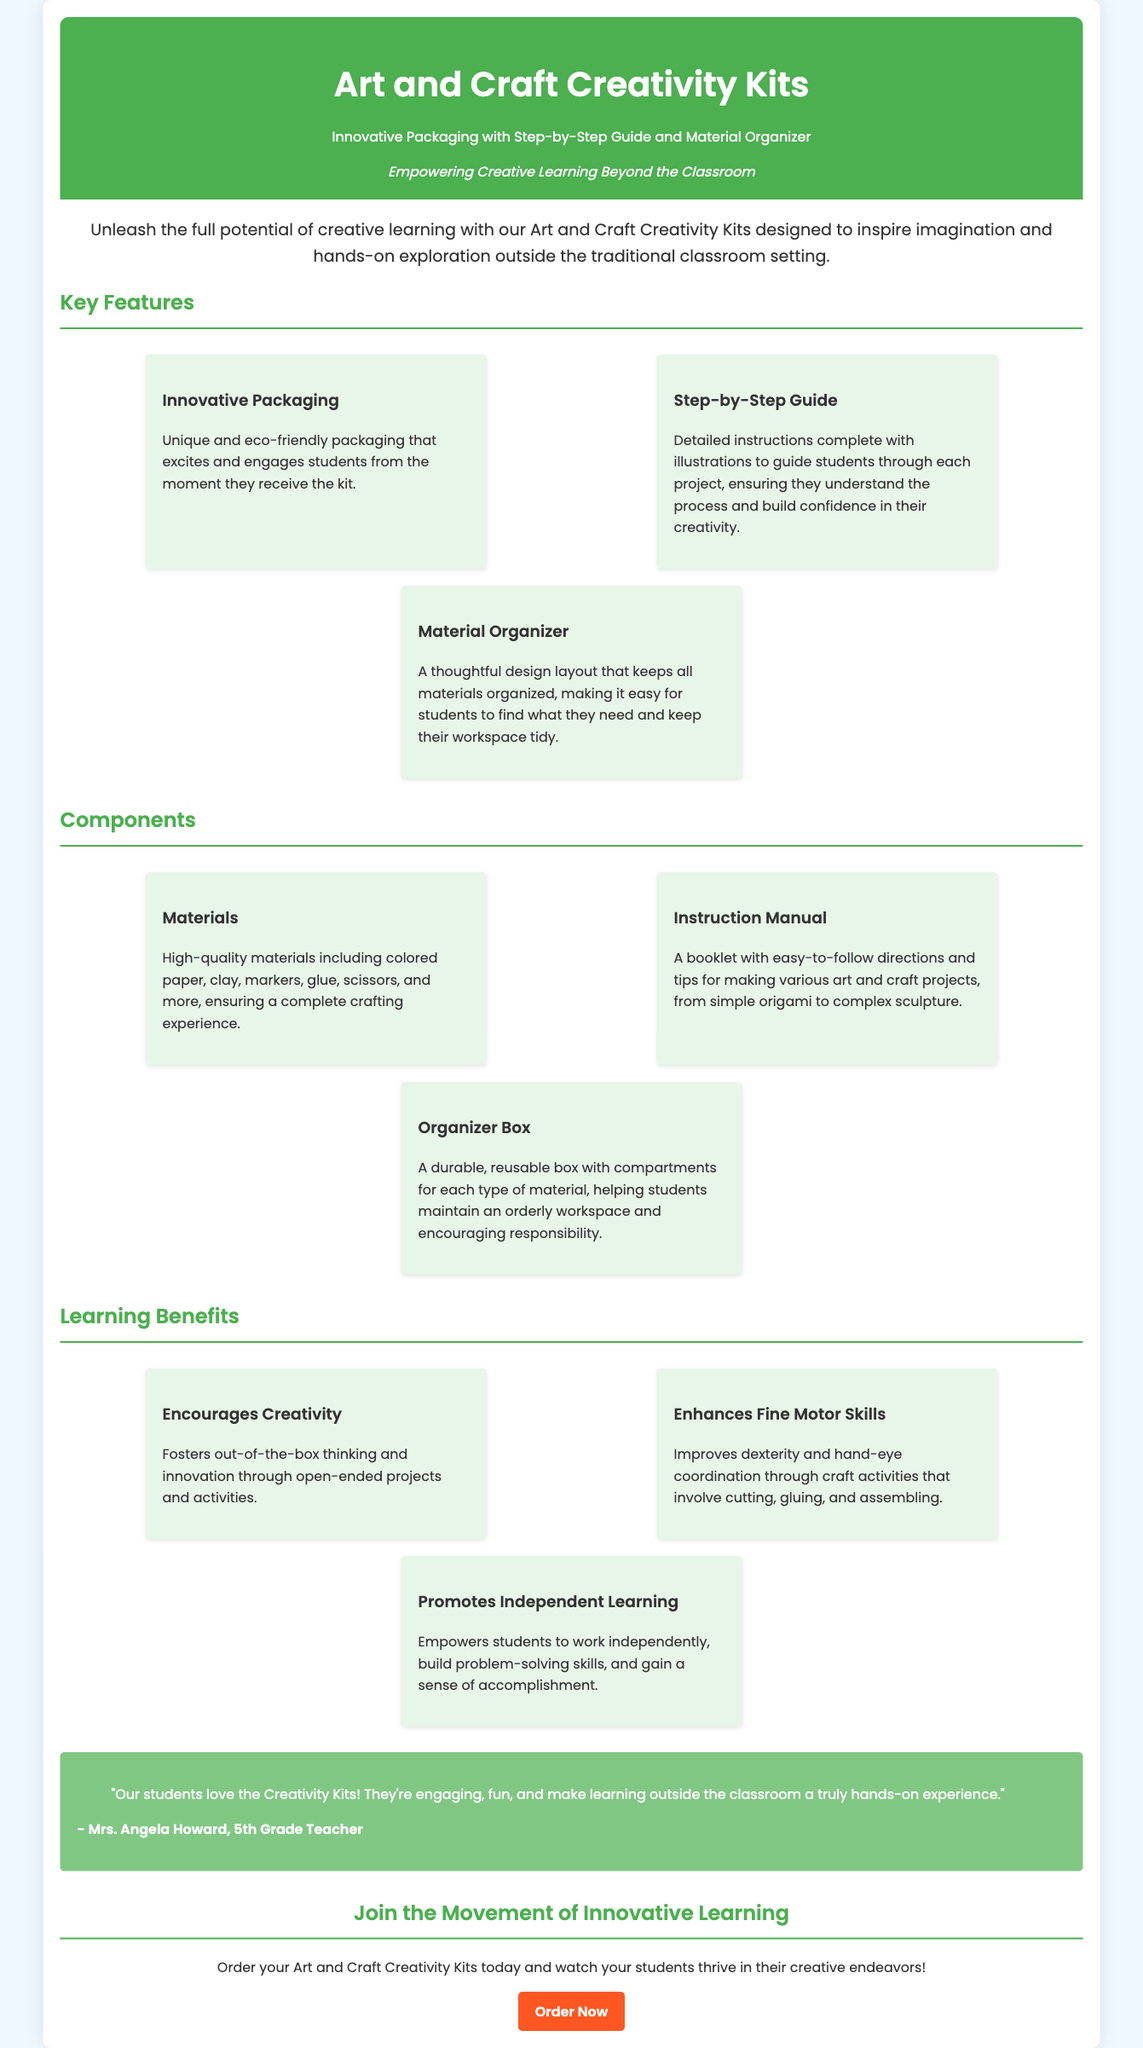What is the title of the product? The title of the product is prominently displayed in the header section of the document.
Answer: Art and Craft Creativity Kits What does the packaging feature? The document specifies key features of the product, one of which is innovative packaging.
Answer: Innovative Packaging How many components are listed in the document? The document provides a section for components and lists three individual items.
Answer: Three Who is quoted in the testimonial? The testimonial section includes a quote attributed to a specific person, identified in the document.
Answer: Mrs. Angela Howard What is one benefit of the creativity kits mentioned in the document? The document highlights several benefits, one of which encourages creativity.
Answer: Encourages Creativity What type of materials are included in the kits? The document provides details about the materials included in the kits, mentioning high-quality items.
Answer: High-quality materials What kind of guide is provided with the kits? The document specifies the type of guide that assists users in utilizing the product effectively.
Answer: Step-by-Step Guide How does the organizer box help students? The document describes the purpose of the organizer box within the context of the product's use.
Answer: Helps maintain an orderly workspace What color is the header background? The document describes the appearance of the header section, including the background color.
Answer: Green 